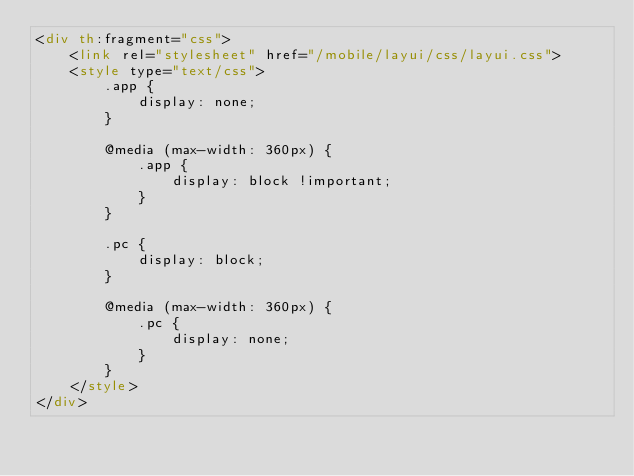Convert code to text. <code><loc_0><loc_0><loc_500><loc_500><_HTML_><div th:fragment="css">
    <link rel="stylesheet" href="/mobile/layui/css/layui.css">
    <style type="text/css">
        .app {
            display: none;
        }

        @media (max-width: 360px) {
            .app {
                display: block !important;
            }
        }

        .pc {
            display: block;
        }

        @media (max-width: 360px) {
            .pc {
                display: none;
            }
        }
    </style>
</div></code> 